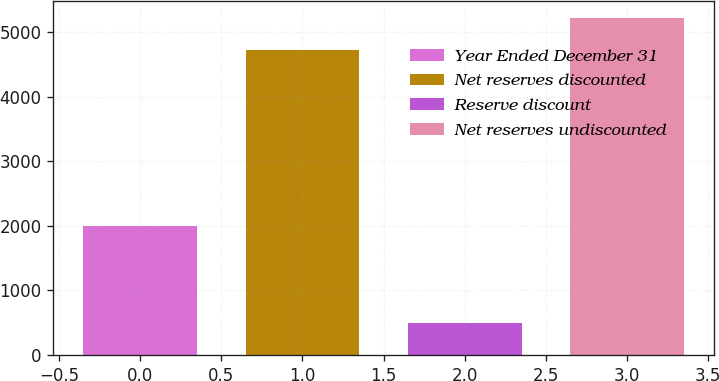<chart> <loc_0><loc_0><loc_500><loc_500><bar_chart><fcel>Year Ended December 31<fcel>Net reserves discounted<fcel>Reserve discount<fcel>Net reserves undiscounted<nl><fcel>2004<fcel>4723<fcel>503<fcel>5226<nl></chart> 